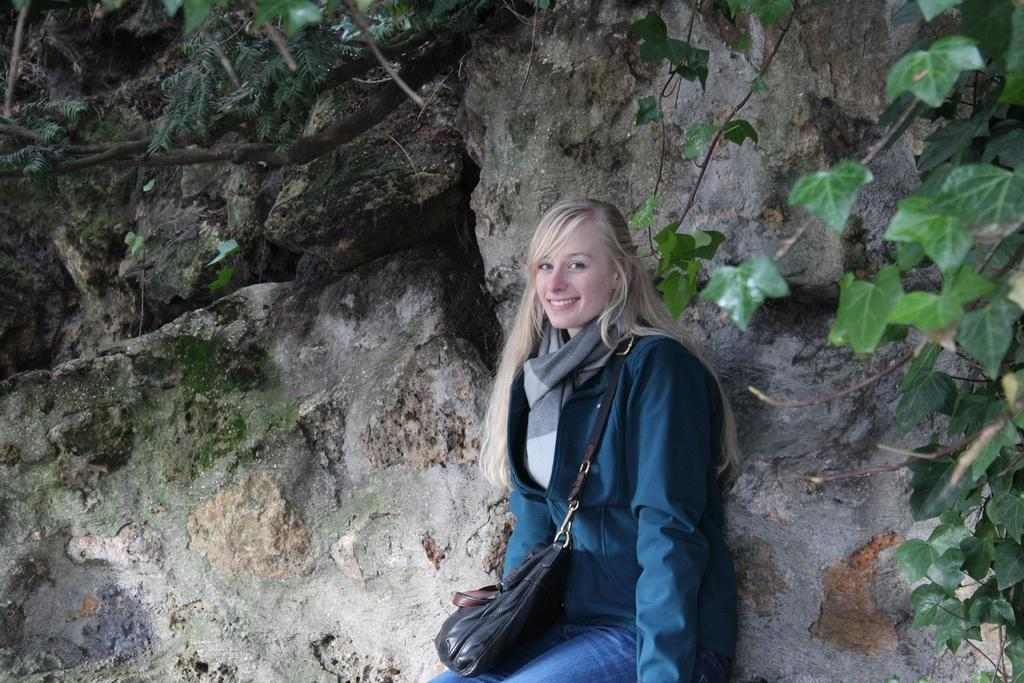Who is the main subject in the image? There is a woman in the image. What is the woman wearing? The woman is wearing a bag. Where is the woman standing? The woman is standing in front of a rock. What type of vegetation can be seen in the image? There are plants visible in the image. What type of berry is the woman picking from the plants in the image? There is no berry present in the image, and the woman is not shown picking anything from the plants. 